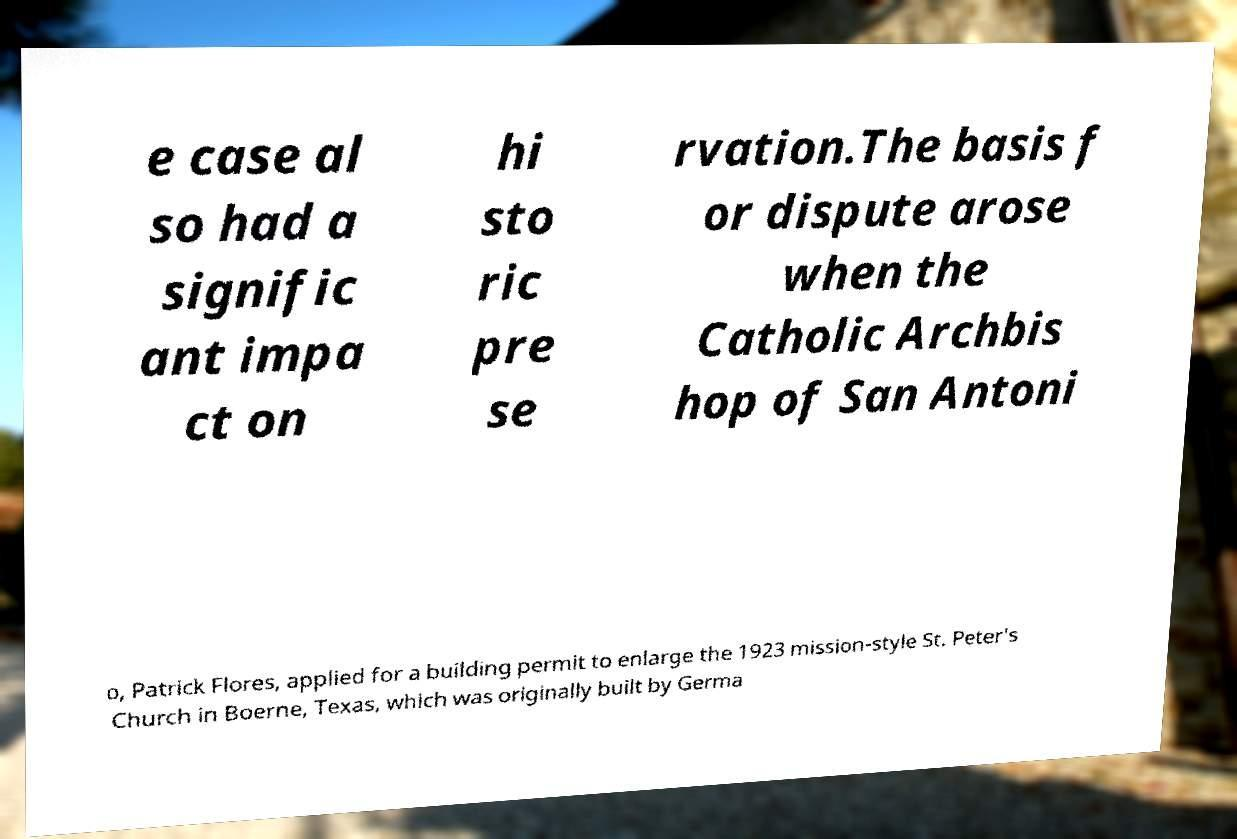There's text embedded in this image that I need extracted. Can you transcribe it verbatim? e case al so had a signific ant impa ct on hi sto ric pre se rvation.The basis f or dispute arose when the Catholic Archbis hop of San Antoni o, Patrick Flores, applied for a building permit to enlarge the 1923 mission-style St. Peter's Church in Boerne, Texas, which was originally built by Germa 